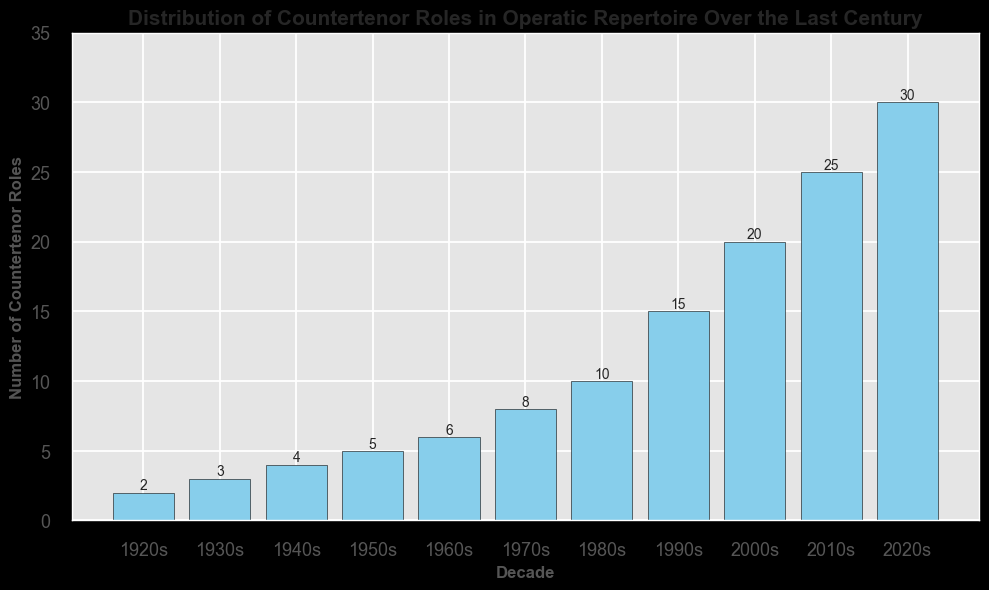What decade has the highest number of countertenor roles? To identify the decade with the highest number of countertenor roles, look for the tallest bar in the chart. The tallest bar corresponds to the 2020s.
Answer: 2020s How many roles were there in total from the 1920s to the 1960s? Sum the numbers from the 1920s to the 1960s: 2 (1920s) + 3 (1930s) + 4 (1940s) + 5 (1950s) + 6 (1960s) = 20.
Answer: 20 Which decades saw an increase in the number of countertenor roles compared to the previous decade? Compare each decade's value with the previous one. There are increases from the 1920s to 1930s, 1930s to 1940s, 1940s to 1950s, 1950s to 1960s, 1960s to 1970s, 1970s to 1980s, 1980s to 1990s, 1990s to 2000s, 2000s to 2010s, and 2010s to 2020s.
Answer: All decades listed What is the total number of countertenor roles from 2000s to 2020s? Sum the numbers from the 2000s to the 2020s: 20 (2000s) + 25 (2010s) + 30 (2020s) = 75.
Answer: 75 By how much did the number of countertenor roles increase from the 1970s to the 1980s? Subtract the number of roles in the 1970s from those in the 1980s: 10 (1980s) - 8 (1970s) = 2.
Answer: 2 What is the average number of countertenor roles per decade over the last century? Sum all the values and then divide by the number of decades. Sum is 2 + 3 + 4 + 5 + 6 + 8 + 10 + 15 + 20 + 25 + 30 = 128. There are 11 decades, so 128 / 11 ≈ 11.64.
Answer: ~11.64 Compare the decade with the smallest number of countertenor roles to the decade with the highest. The smallest number is in the 1920s (2 roles) and the highest is in the 2020s (30 roles). The difference is 30 - 2 = 28.
Answer: 28 What visual element identifies the number of roles in each decade? The height of each bar represents the number of roles for that decade; taller bars indicate more roles.
Answer: Height of bars How did the number of countertenor roles change from the 1990s to the 2020s? From the 1990s to the 2020s, the numbers increased as follows: 15 (1990s) to 20 (2000s), 20 (2000s) to 25 (2010s), and 25 (2010s) to 30 (2020s).
Answer: Increased What is the trend in the number of countertenor roles from the 1920s to the 2020s? The general trend shows a steady increase in the number of countertenor roles over the decades, with some decades having more significant increases than others.
Answer: Increasing 